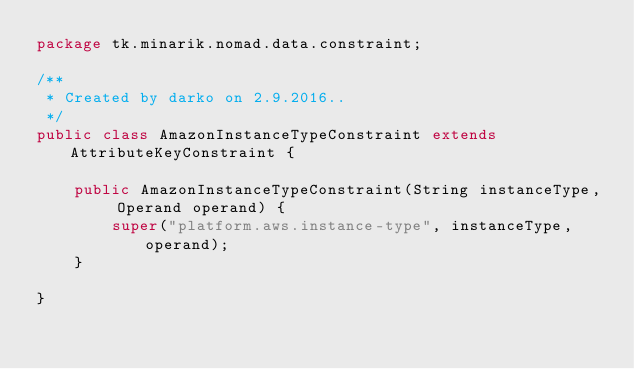<code> <loc_0><loc_0><loc_500><loc_500><_Java_>package tk.minarik.nomad.data.constraint;

/**
 * Created by darko on 2.9.2016..
 */
public class AmazonInstanceTypeConstraint extends AttributeKeyConstraint {

    public AmazonInstanceTypeConstraint(String instanceType, Operand operand) {
        super("platform.aws.instance-type", instanceType, operand);
    }

}
</code> 